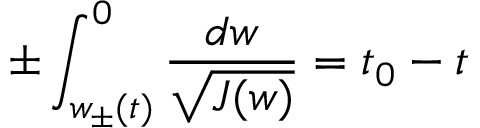<formula> <loc_0><loc_0><loc_500><loc_500>\pm \int _ { w _ { \pm } ( t ) } ^ { 0 } \frac { d w } { \sqrt { J ( w ) } } = t _ { 0 } - t</formula> 